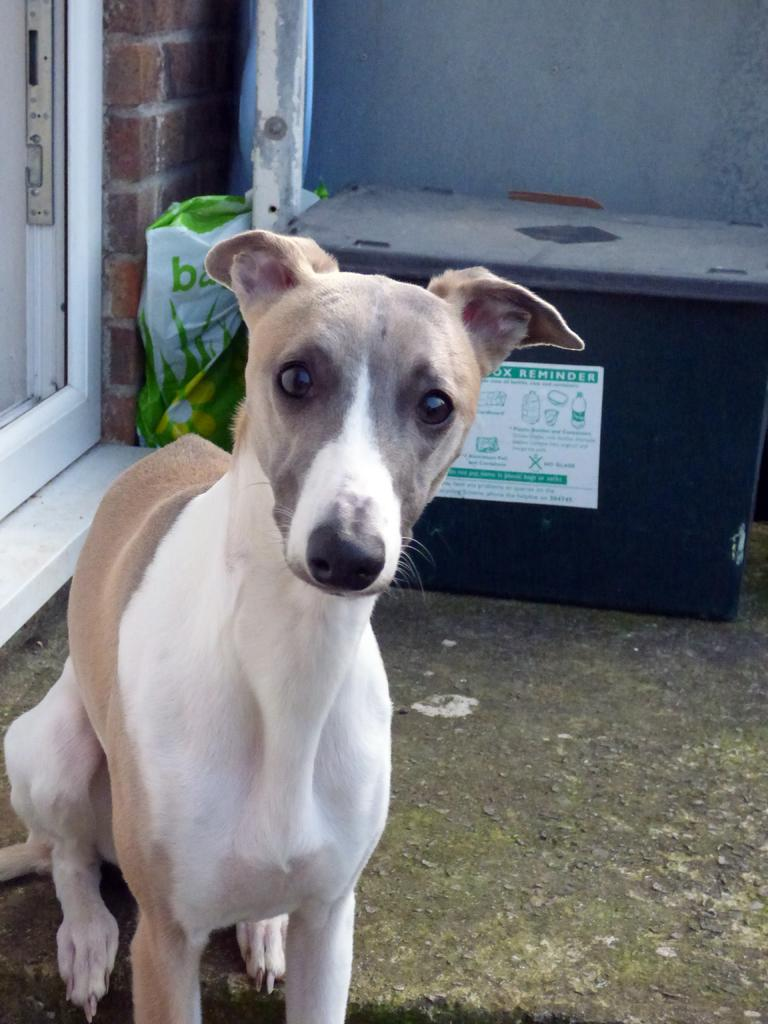What animal is sitting in the image? There is a dog sitting in the image. Where is the door located in the image? The door is on the left side of the image. What can be seen in the background of the image? There is a wall in the background of the image. What objects are in the middle of the image? There is a box and a bag in the middle of the image. How many jellyfish are swimming in the image? There are no jellyfish present in the image. What type of fork is being used to eat the food in the image? There is no fork visible in the image, and no food is being eaten. 